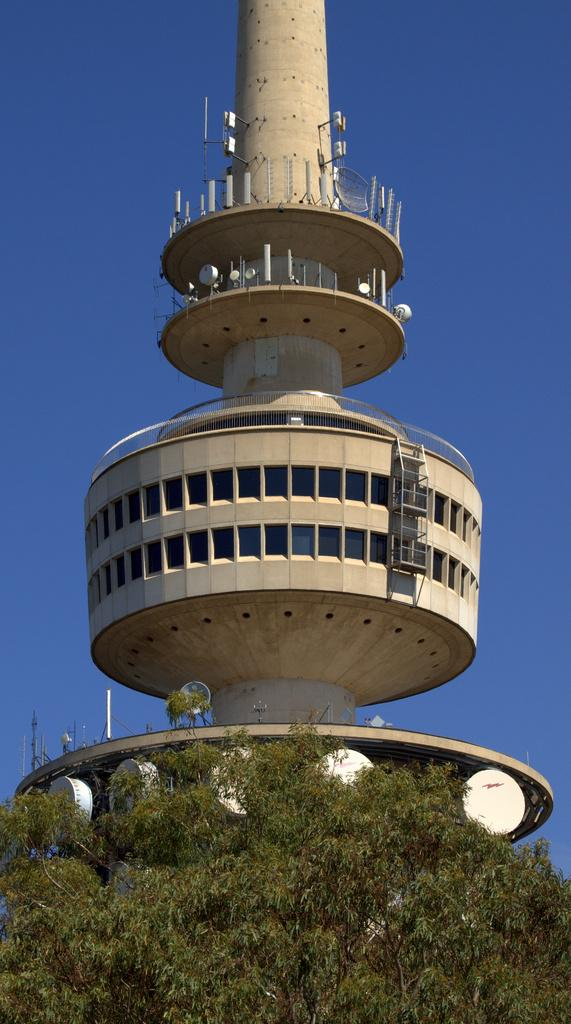What type of structure is in the image? There is a tower building in the image. What is located at the bottom of the image? There are trees at the bottom of the image. What can be seen in the background of the image? The sky is visible in the background of the image. How many toes are visible on the tower building in the image? There are no toes present on the tower building in the image. 